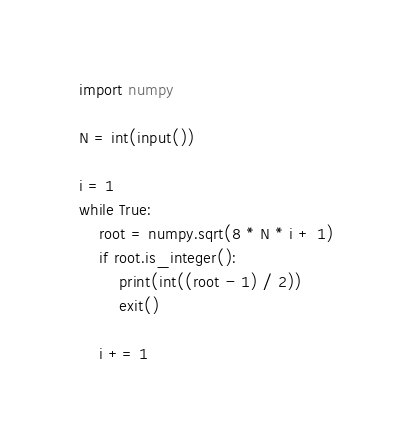<code> <loc_0><loc_0><loc_500><loc_500><_Python_>import numpy

N = int(input())

i = 1
while True:
    root = numpy.sqrt(8 * N * i + 1)
    if root.is_integer():
        print(int((root - 1) / 2))
        exit()

    i += 1
</code> 